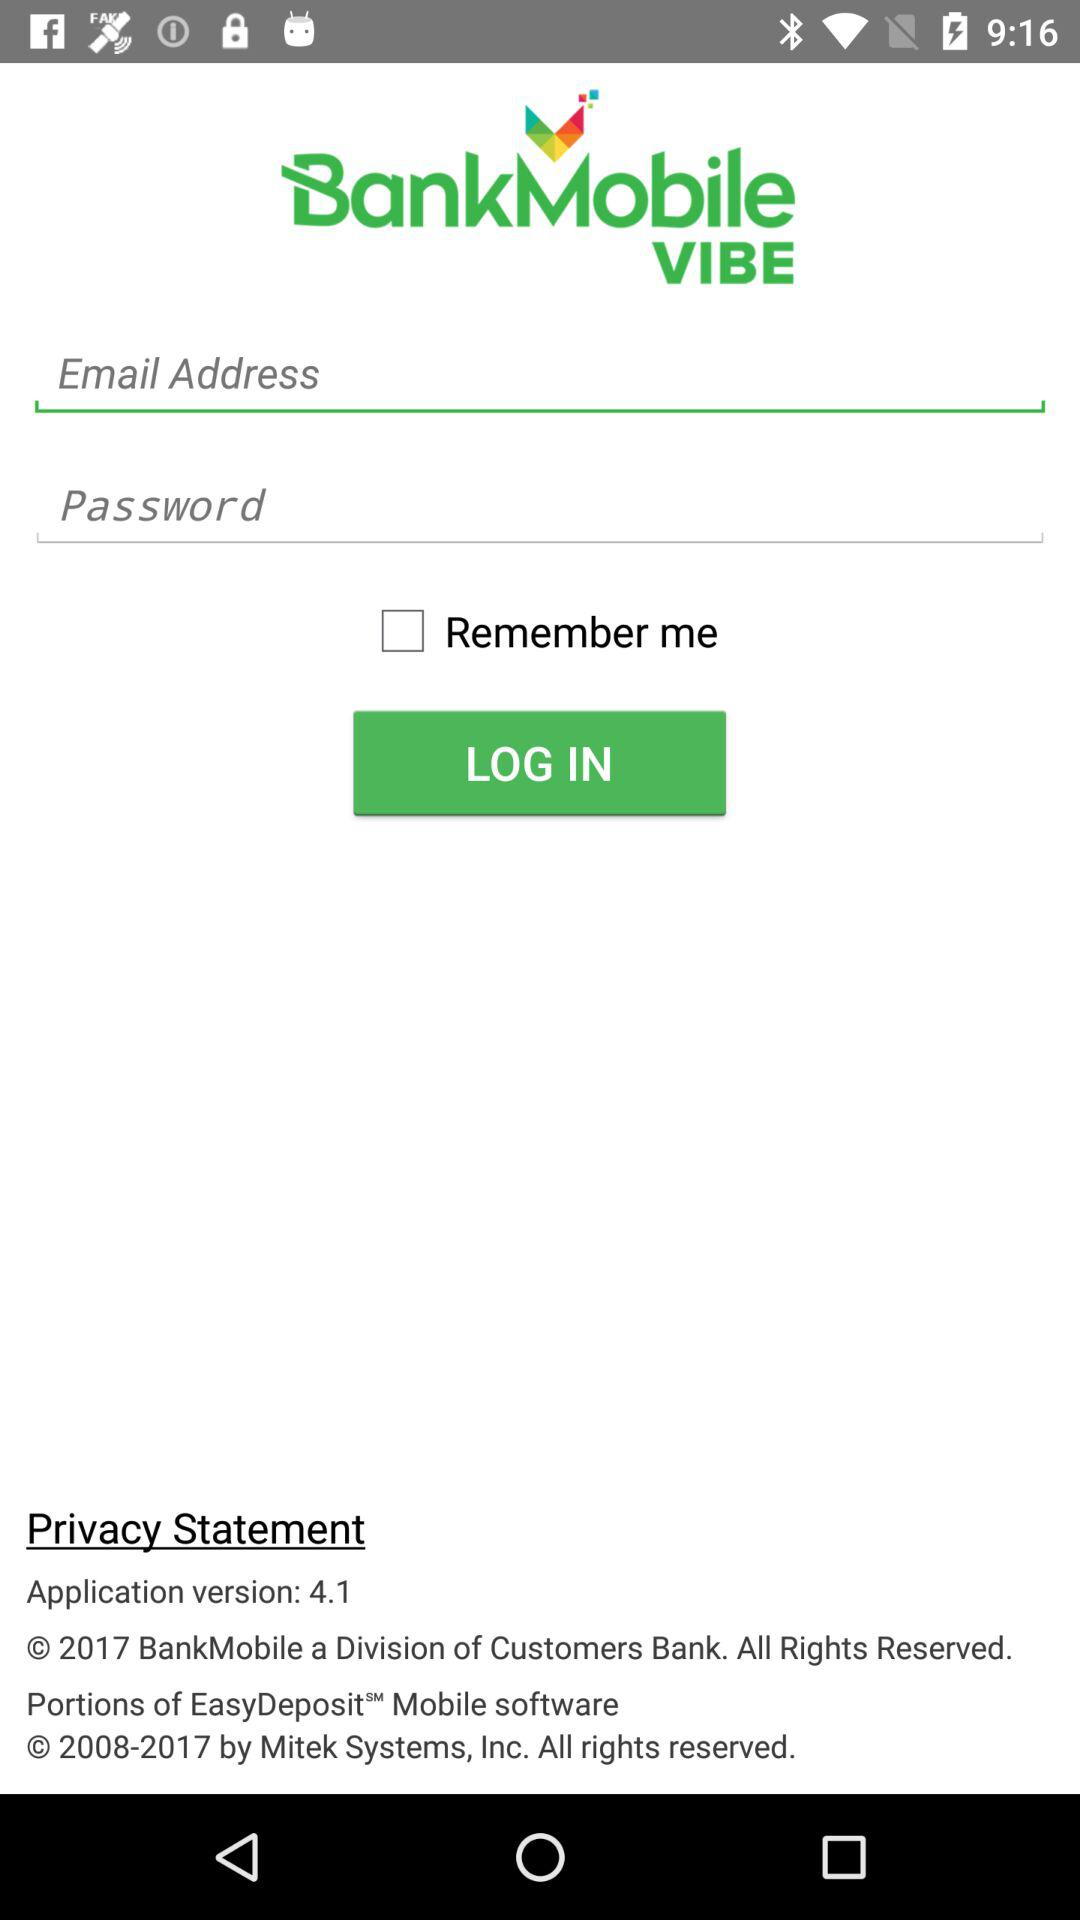What is the status of "Remember me"? The status of "Remember me" is "off". 